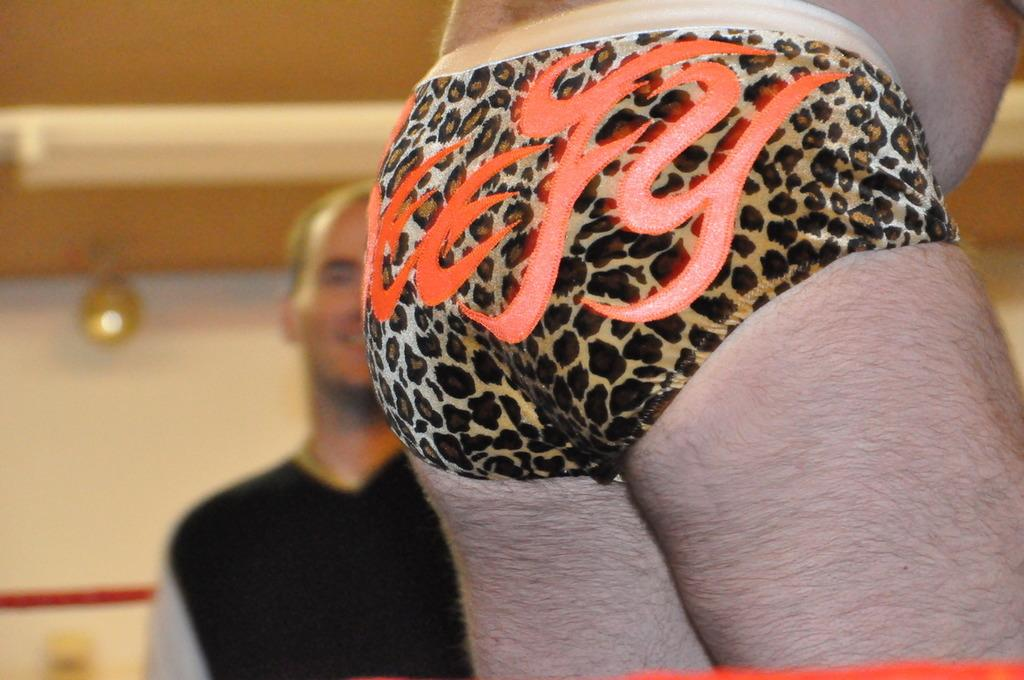What is the position of the person in the picture? The person in the picture has their back facing the camera. Can you describe the man in the image? There is a man standing and smiling in the image. What can be seen in the background of the image? There is a wall visible in the background of the image. How is the wall being illuminated in the image? There is a light source illuminating the wall in the image. Reasoning: To produce the conversation, we first identify the main subjects in the image, which are the person and the man. We then describe their positions and actions, as well as the background and lighting. Each question is designed to elicit a specific detail about the image that is known from the provided facts. Absurd Question/Answer: How many frogs are jumping on the ground in the image? There are no frogs present in the image. What type of ground can be seen in the image? The ground is not visible in the image, as the focus is on the person and the man. How many frogs are jumping on the ground in the image? There are no frogs present in the image. What type of ground can be seen in the image? The ground is not visible in the image, as the focus is on the person and the man. 